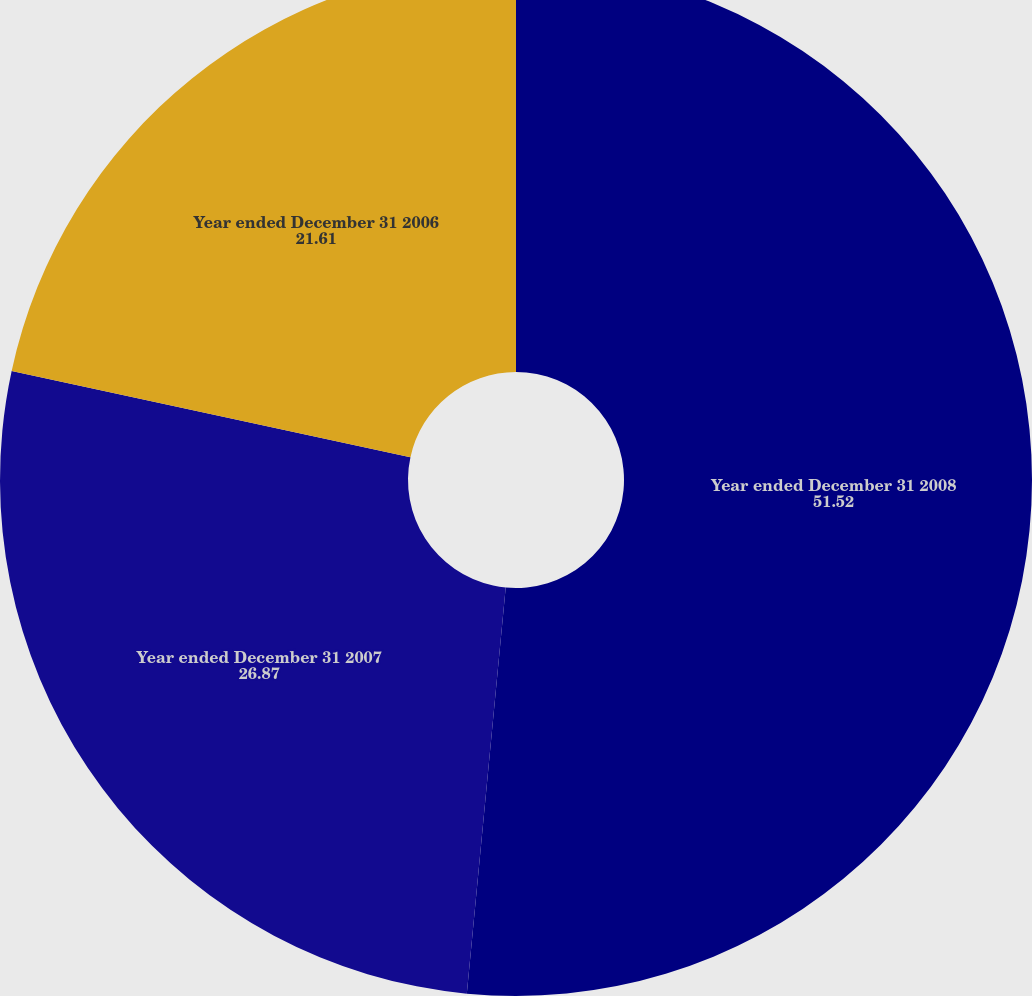Convert chart. <chart><loc_0><loc_0><loc_500><loc_500><pie_chart><fcel>Year ended December 31 2008<fcel>Year ended December 31 2007<fcel>Year ended December 31 2006<nl><fcel>51.52%<fcel>26.87%<fcel>21.61%<nl></chart> 